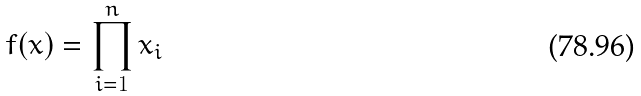Convert formula to latex. <formula><loc_0><loc_0><loc_500><loc_500>f ( x ) = \prod _ { i = 1 } ^ { n } x _ { i }</formula> 